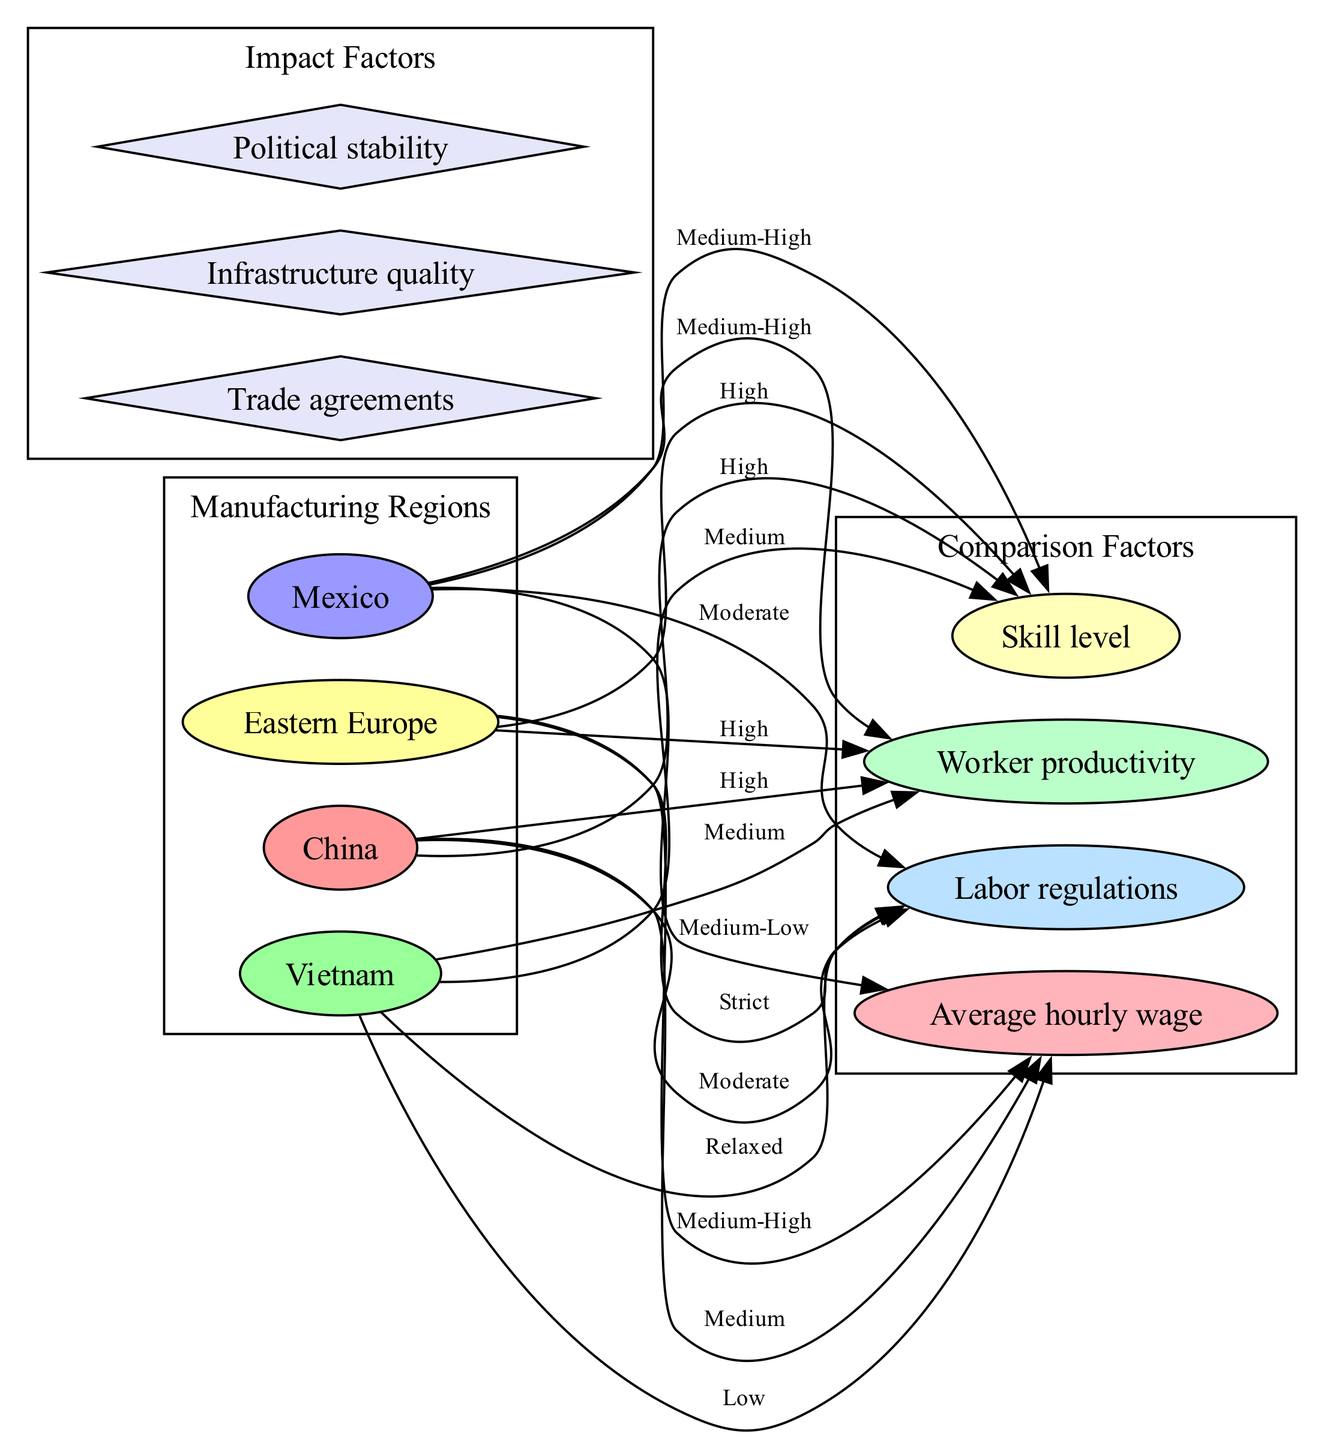What is the average hourly wage in Vietnam? The node for "Average hourly wage" linked from Vietnam shows the label "Low." This directly indicates the average wage in that region.
Answer: Low Which region has the highest worker productivity? By examining the edges connected to "Worker productivity," we see that both China and Eastern Europe are labeled "High." However, since this question is about the highest, we recognize that they are both high but cannot distinguish further based on the given diagram. Hence, a reasonable answer would refer to both regions.
Answer: China and Eastern Europe What is the skill level in Mexico? The edge from Mexico to "Skill level" indicates the label "Medium-High." Thus, this reflects the skill level associated with Mexico.
Answer: Medium-High Which region has the strictest labor regulations? The analysis of the "Labor regulations" edge reveals that Eastern Europe is labeled "Strict," which is the highest level of regulation depicted in the diagram.
Answer: Eastern Europe What is the relationship between productivity in Vietnam and labor regulations? Referring to the edges, Vietnam links to "Worker productivity" labeled "Medium" and to "Labor regulations" labeled "Relaxed." Thus, it indicates that Vietnam has moderate productivity and relaxed regulations.
Answer: Medium productivity and relaxed regulations Which region’s average hourly wage is categorized as medium-high? The edge linked to "Average hourly wage" shows that Eastern Europe has a "Medium-High" wage classification, indicating the average wage level in that region.
Answer: Eastern Europe Which region shows a medium-level in both productivity and skill? Looking at the edges connecting to both "Worker productivity" and "Skill level," Mexico shows both to be greater than low but less than high compared to the other regions. Thus, Mexico is identified here.
Answer: Mexico What are three impact factors listed in the diagram? The diagram has a section named "Impact Factors," where three nodes are shown: "Trade agreements," "Infrastructure quality," and "Political stability." Listing these provides a succinct answer to the inquiry.
Answer: Trade agreements, Infrastructure quality, Political stability Which region has a medium-low average wage? The edge connected to "Average hourly wage" for Mexico reveals the classification "Medium-Low," indicating it is the region represented by this wage level.
Answer: Mexico 